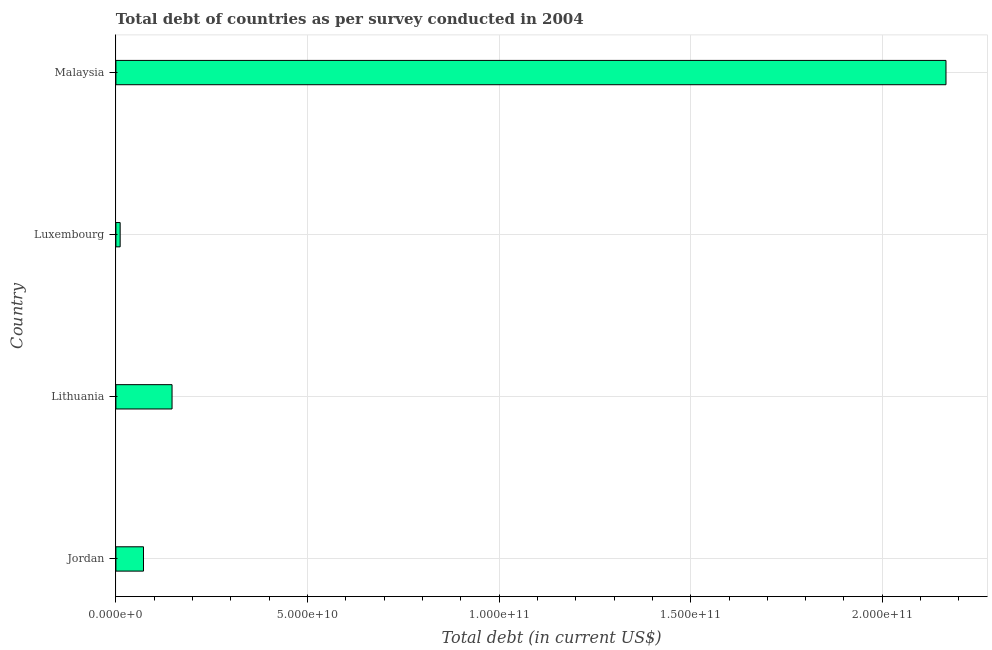Does the graph contain any zero values?
Ensure brevity in your answer.  No. Does the graph contain grids?
Your answer should be very brief. Yes. What is the title of the graph?
Keep it short and to the point. Total debt of countries as per survey conducted in 2004. What is the label or title of the X-axis?
Provide a short and direct response. Total debt (in current US$). What is the total debt in Luxembourg?
Your answer should be compact. 1.11e+09. Across all countries, what is the maximum total debt?
Your answer should be very brief. 2.17e+11. Across all countries, what is the minimum total debt?
Offer a very short reply. 1.11e+09. In which country was the total debt maximum?
Your answer should be compact. Malaysia. In which country was the total debt minimum?
Provide a succinct answer. Luxembourg. What is the sum of the total debt?
Ensure brevity in your answer.  2.40e+11. What is the difference between the total debt in Jordan and Lithuania?
Keep it short and to the point. -7.45e+09. What is the average total debt per country?
Make the answer very short. 5.99e+1. What is the median total debt?
Offer a very short reply. 1.09e+1. In how many countries, is the total debt greater than 150000000000 US$?
Ensure brevity in your answer.  1. What is the ratio of the total debt in Luxembourg to that in Malaysia?
Give a very brief answer. 0.01. Is the total debt in Jordan less than that in Lithuania?
Provide a short and direct response. Yes. What is the difference between the highest and the second highest total debt?
Make the answer very short. 2.02e+11. Is the sum of the total debt in Jordan and Luxembourg greater than the maximum total debt across all countries?
Your answer should be compact. No. What is the difference between the highest and the lowest total debt?
Your answer should be very brief. 2.16e+11. In how many countries, is the total debt greater than the average total debt taken over all countries?
Give a very brief answer. 1. How many bars are there?
Your answer should be very brief. 4. How many countries are there in the graph?
Provide a short and direct response. 4. What is the Total debt (in current US$) of Jordan?
Provide a short and direct response. 7.20e+09. What is the Total debt (in current US$) of Lithuania?
Your response must be concise. 1.47e+1. What is the Total debt (in current US$) in Luxembourg?
Your answer should be compact. 1.11e+09. What is the Total debt (in current US$) of Malaysia?
Offer a very short reply. 2.17e+11. What is the difference between the Total debt (in current US$) in Jordan and Lithuania?
Provide a short and direct response. -7.45e+09. What is the difference between the Total debt (in current US$) in Jordan and Luxembourg?
Provide a succinct answer. 6.09e+09. What is the difference between the Total debt (in current US$) in Jordan and Malaysia?
Provide a succinct answer. -2.09e+11. What is the difference between the Total debt (in current US$) in Lithuania and Luxembourg?
Offer a very short reply. 1.35e+1. What is the difference between the Total debt (in current US$) in Lithuania and Malaysia?
Make the answer very short. -2.02e+11. What is the difference between the Total debt (in current US$) in Luxembourg and Malaysia?
Provide a short and direct response. -2.16e+11. What is the ratio of the Total debt (in current US$) in Jordan to that in Lithuania?
Give a very brief answer. 0.49. What is the ratio of the Total debt (in current US$) in Jordan to that in Luxembourg?
Ensure brevity in your answer.  6.47. What is the ratio of the Total debt (in current US$) in Jordan to that in Malaysia?
Give a very brief answer. 0.03. What is the ratio of the Total debt (in current US$) in Lithuania to that in Luxembourg?
Offer a terse response. 13.16. What is the ratio of the Total debt (in current US$) in Lithuania to that in Malaysia?
Give a very brief answer. 0.07. What is the ratio of the Total debt (in current US$) in Luxembourg to that in Malaysia?
Offer a very short reply. 0.01. 